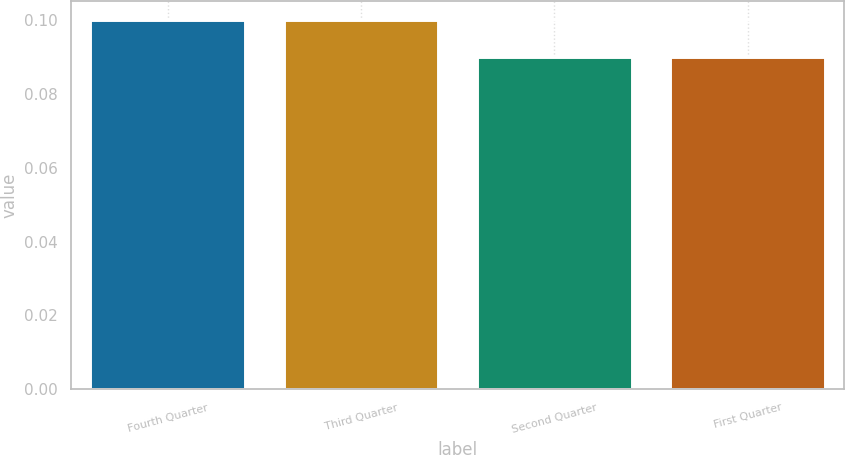Convert chart. <chart><loc_0><loc_0><loc_500><loc_500><bar_chart><fcel>Fourth Quarter<fcel>Third Quarter<fcel>Second Quarter<fcel>First Quarter<nl><fcel>0.1<fcel>0.1<fcel>0.09<fcel>0.09<nl></chart> 